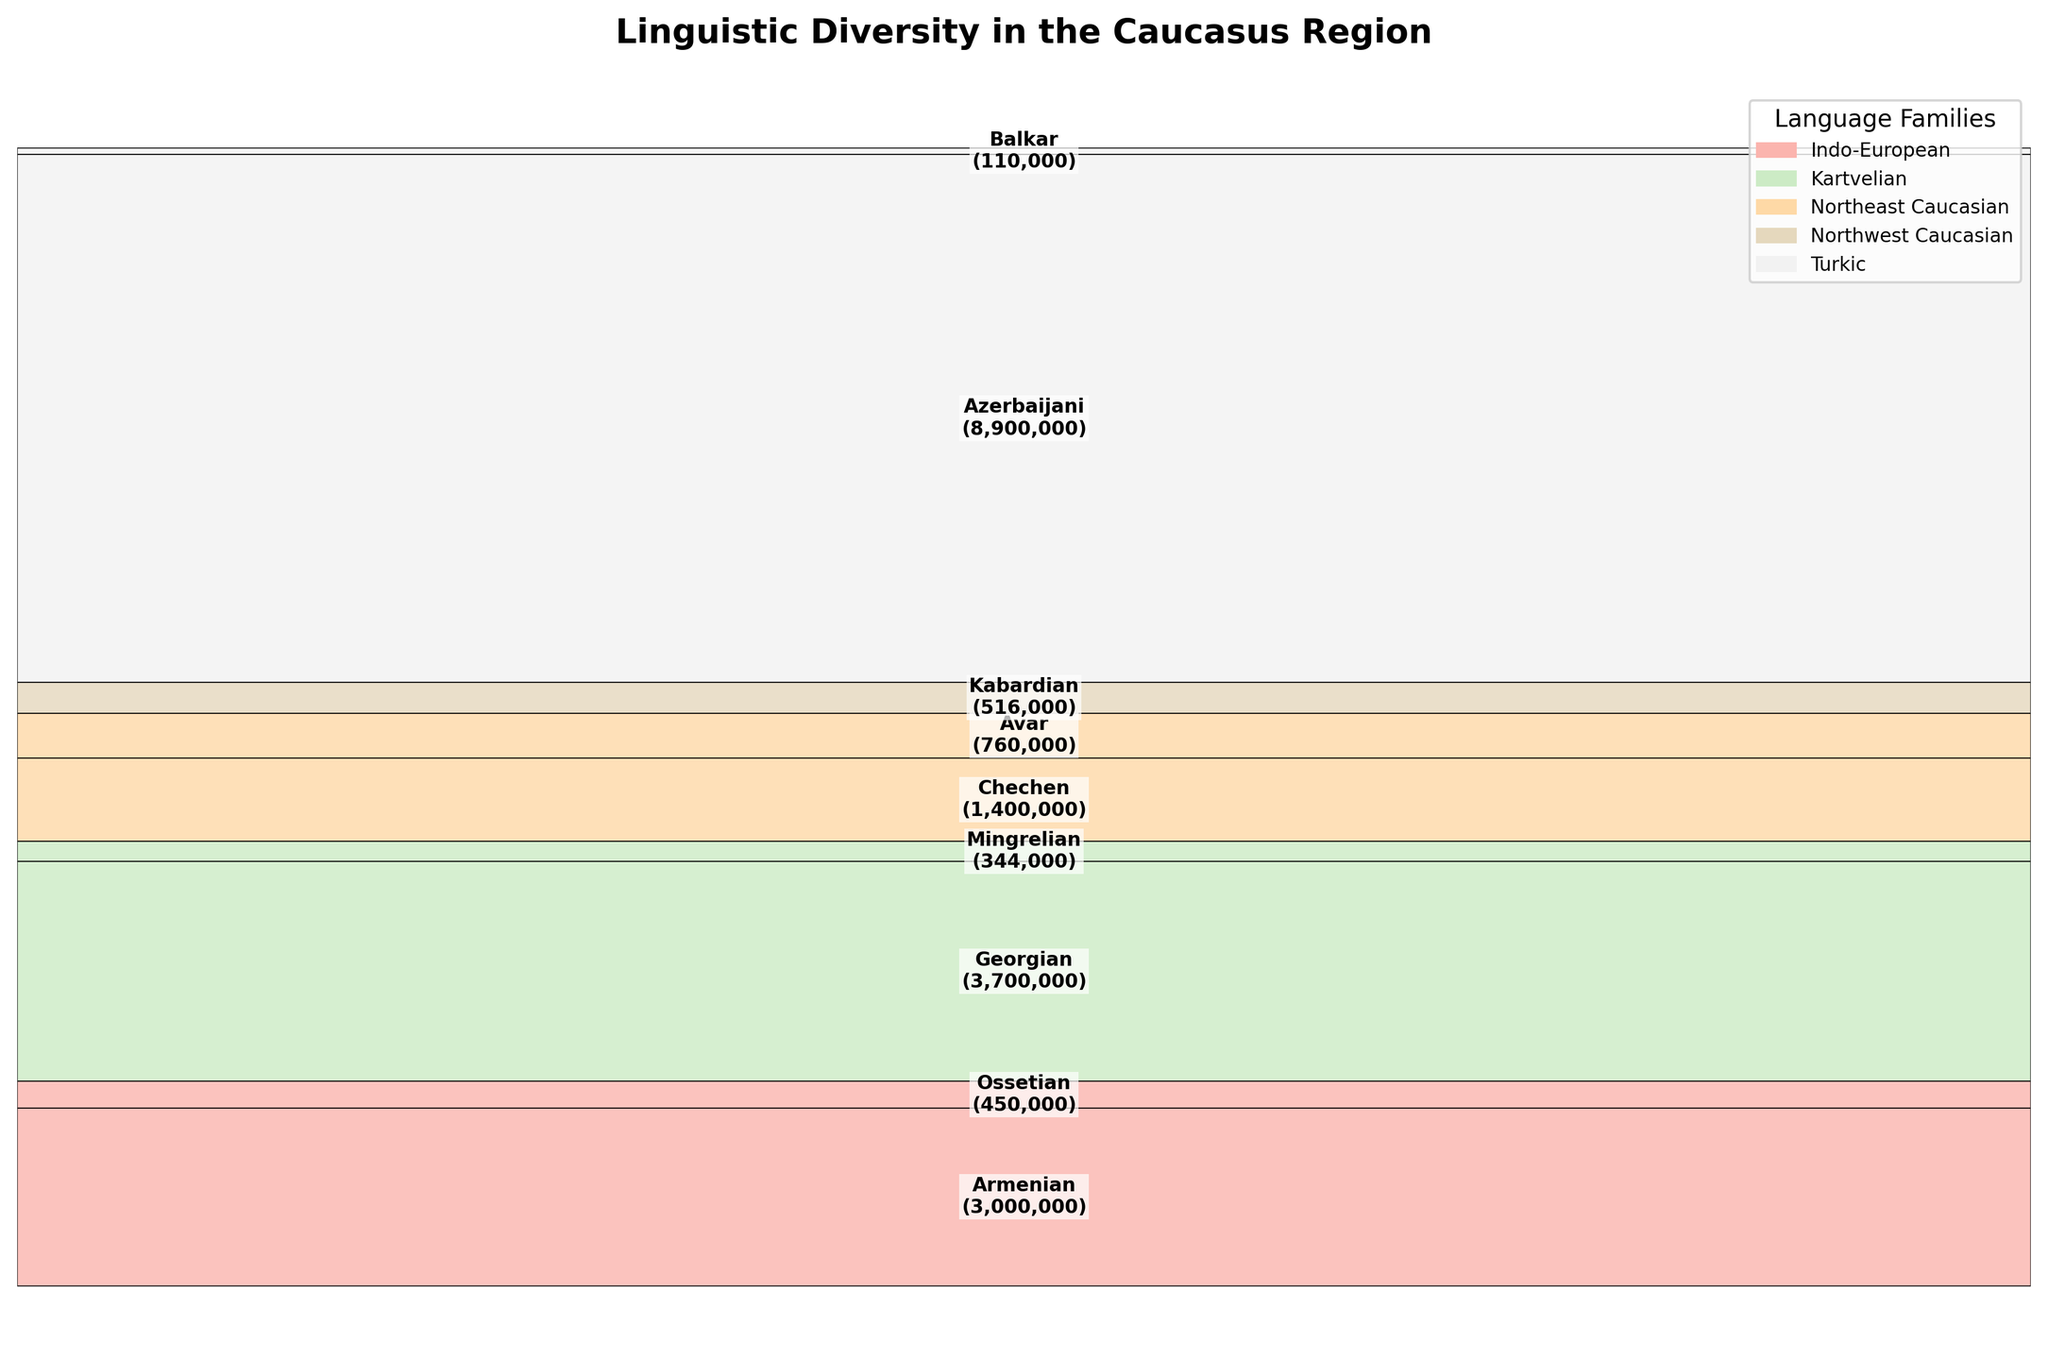What's the title of the plot? The title is located at the top of the figure and is displayed in a larger, bold font specifically to denote the primary topic of the visualization.
Answer: Linguistic Diversity in the Caucasus Region How many language families are depicted in the plot? Each language family is represented by a unique color in the legend, and we can count the number of different colored rectangles in the legend to determine the number of language families.
Answer: 5 Which dialect has the largest population? By observing the plot, the largest rectangle represents the dialect with the biggest population. The text within this rectangle will provide the name and population size.
Answer: Azerbaijani What's the combined population of dialects from the Kartvelian language family? Locate the rectangles representing Kartvelian dialects (Georgian and Mingrelian), sum their respective populations (3,700,000 + 344,000).
Answer: 4,044,000 Compare the population sizes of Ossetian and Avar dialects. Which one is larger? Identify the rectangles corresponding to Ossetian and Avar, check the population in the text labels, and compare the two values (450,000 vs. 760,000).
Answer: Avar is larger Which geographical area has the smallest population among the plotted dialects? Identify the smallest rectangle in the plot. The text within the rectangle will specify the dialect and the geographical area it represents.
Answer: Balkar (Kabardino-Balkaria) How many dialects belong to the Indo-European language family? Refer to the legend to see which dialects are color-coded for Indo-European and then count the number of rectangles with this specific color in the plot.
Answer: 2 What's the average population of the Northeast Caucasian dialects? Identify the Northeast Caucasian dialects (Chechen, Avar), sum their populations (1,400,000 + 760,000), and divide by the number of dialects (2). (1,400,000 + 760,000) / 2.
Answer: 1,080,000 Name two language families that each have only one dialect represented in the plot. Check the legend to see which language families have only one color block and ensure that these families each correspond to only one rectangle in the plot.
Answer: Northwest Caucasian and Indo-European 